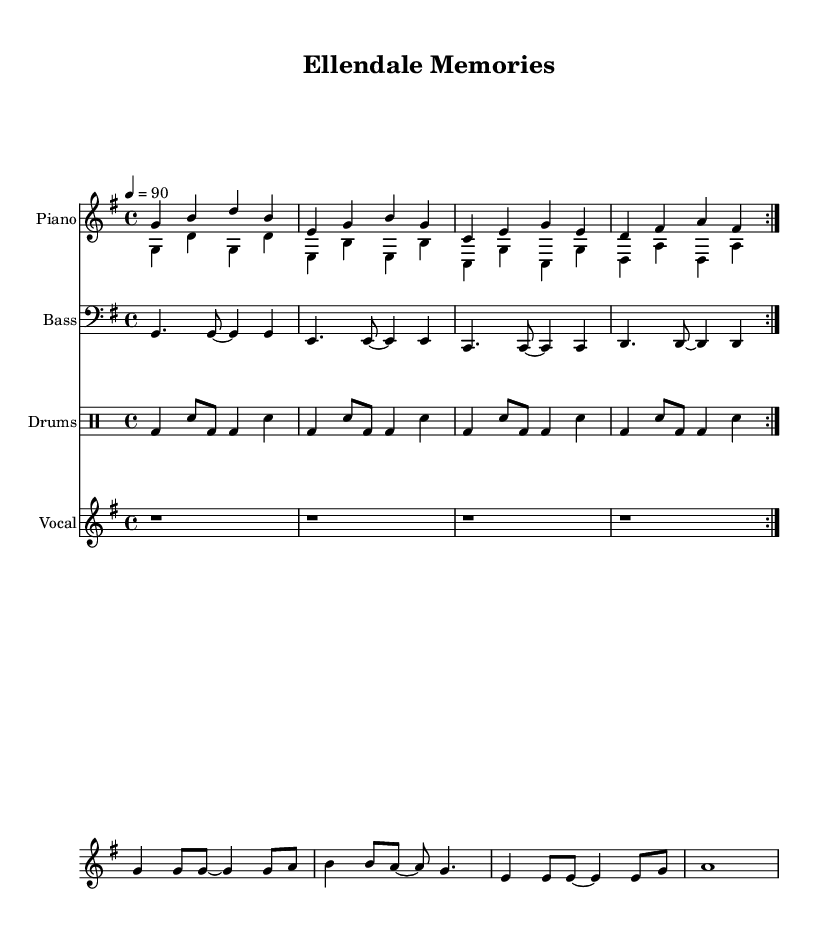What is the key signature of this music? The key signature is G major, indicated by one sharp (F#) at the beginning of the staff.
Answer: G major What is the time signature of this music? The time signature is explicitly marked as 4/4, meaning there are four beats in each measure.
Answer: 4/4 What is the tempo marking of this piece? The tempo is shown as 4 = 90, which indicates that there are 90 beats per minute.
Answer: 90 How many bars are there in the vocal melody section? The vocal melody section has four measures based on the layout of the notation.
Answer: Four What is the musical instrument for the bass line? The bass line is written in a clef designated for bass instruments, meaning it is for bass guitar.
Answer: Bass Which city is referenced in the title of this piece? The title "Ellendale Memories" indicates that the song references the small town of Ellendale.
Answer: Ellendale What type of music genre is this sheet music representing? The sheet music is crafted in the hip-hop genre, as evidenced by the rhythmic structure and lyrical content.
Answer: Hip-hop 